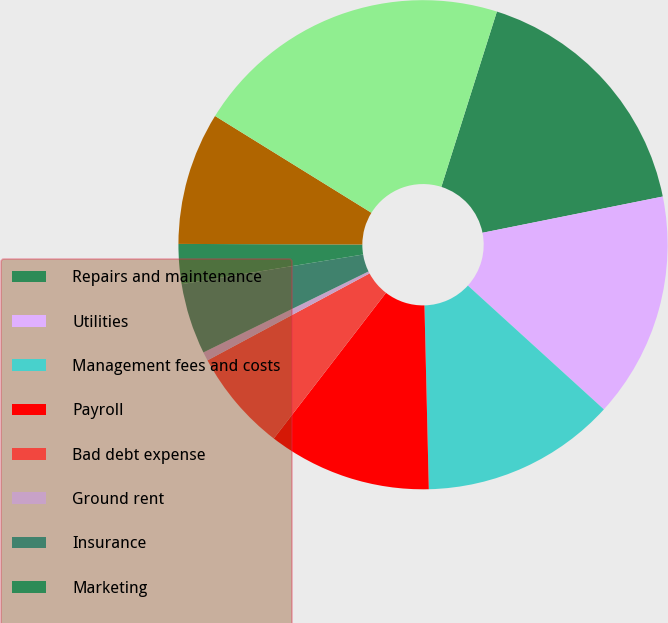Convert chart. <chart><loc_0><loc_0><loc_500><loc_500><pie_chart><fcel>Repairs and maintenance<fcel>Utilities<fcel>Management fees and costs<fcel>Payroll<fcel>Bad debt expense<fcel>Ground rent<fcel>Insurance<fcel>Marketing<fcel>Other operating<fcel>Total rental expenses<nl><fcel>16.96%<fcel>14.91%<fcel>12.87%<fcel>10.82%<fcel>6.72%<fcel>0.58%<fcel>4.68%<fcel>2.63%<fcel>8.77%<fcel>21.06%<nl></chart> 